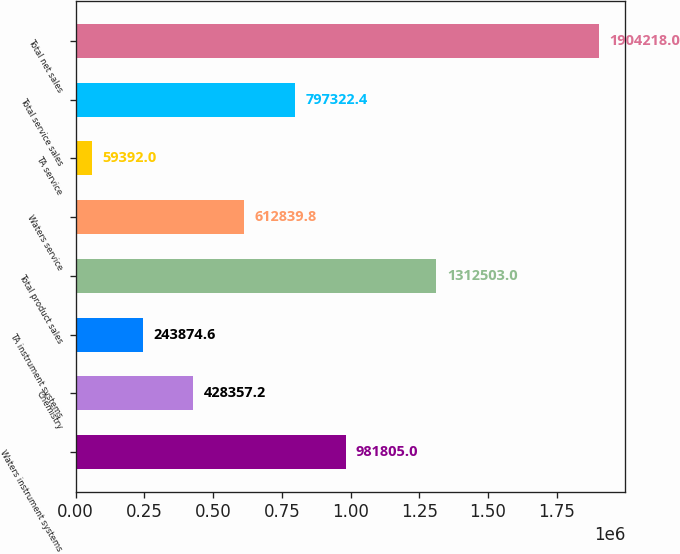Convert chart. <chart><loc_0><loc_0><loc_500><loc_500><bar_chart><fcel>Waters instrument systems<fcel>Chemistry<fcel>TA instrument systems<fcel>Total product sales<fcel>Waters service<fcel>TA service<fcel>Total service sales<fcel>Total net sales<nl><fcel>981805<fcel>428357<fcel>243875<fcel>1.3125e+06<fcel>612840<fcel>59392<fcel>797322<fcel>1.90422e+06<nl></chart> 